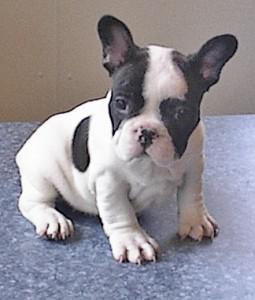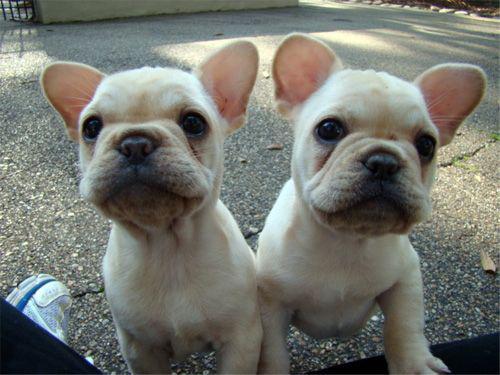The first image is the image on the left, the second image is the image on the right. Assess this claim about the two images: "There are two puppies in the right image.". Correct or not? Answer yes or no. Yes. 